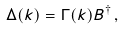Convert formula to latex. <formula><loc_0><loc_0><loc_500><loc_500>\Delta ( k ) = \Gamma ( k ) B ^ { \dagger } \, ,</formula> 